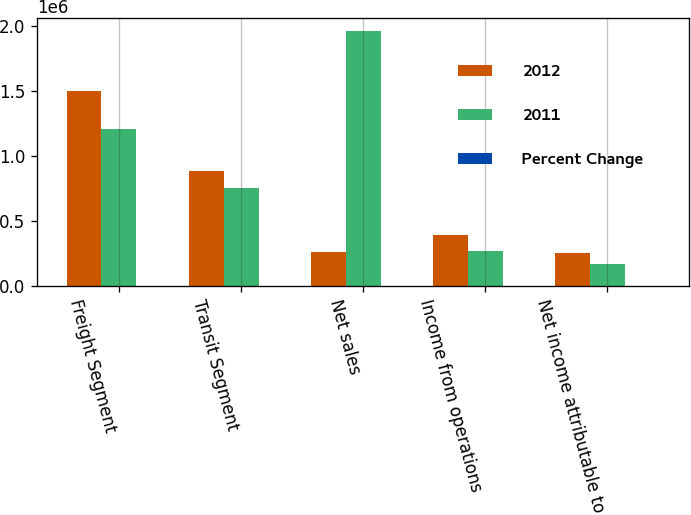Convert chart to OTSL. <chart><loc_0><loc_0><loc_500><loc_500><stacked_bar_chart><ecel><fcel>Freight Segment<fcel>Transit Segment<fcel>Net sales<fcel>Income from operations<fcel>Net income attributable to<nl><fcel>2012<fcel>1.50191e+06<fcel>889211<fcel>261216<fcel>392279<fcel>251732<nl><fcel>2011<fcel>1.21006e+06<fcel>757578<fcel>1.96764e+06<fcel>270701<fcel>170149<nl><fcel>Percent Change<fcel>24.1<fcel>17.4<fcel>21.5<fcel>44.9<fcel>47.9<nl></chart> 